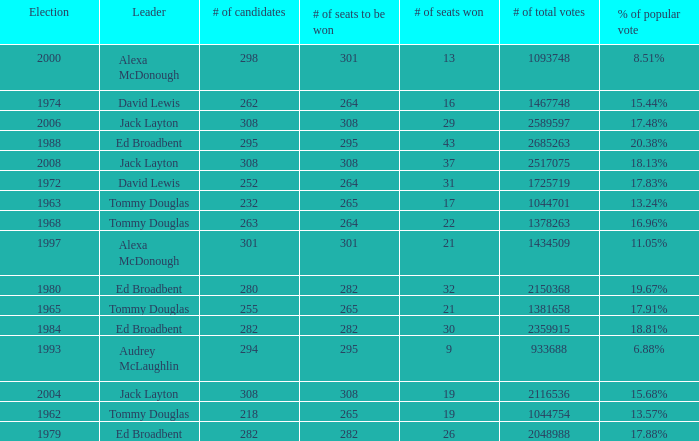Parse the full table. {'header': ['Election', 'Leader', '# of candidates', '# of seats to be won', '# of seats won', '# of total votes', '% of popular vote'], 'rows': [['2000', 'Alexa McDonough', '298', '301', '13', '1093748', '8.51%'], ['1974', 'David Lewis', '262', '264', '16', '1467748', '15.44%'], ['2006', 'Jack Layton', '308', '308', '29', '2589597', '17.48%'], ['1988', 'Ed Broadbent', '295', '295', '43', '2685263', '20.38%'], ['2008', 'Jack Layton', '308', '308', '37', '2517075', '18.13%'], ['1972', 'David Lewis', '252', '264', '31', '1725719', '17.83%'], ['1963', 'Tommy Douglas', '232', '265', '17', '1044701', '13.24%'], ['1968', 'Tommy Douglas', '263', '264', '22', '1378263', '16.96%'], ['1997', 'Alexa McDonough', '301', '301', '21', '1434509', '11.05%'], ['1980', 'Ed Broadbent', '280', '282', '32', '2150368', '19.67%'], ['1965', 'Tommy Douglas', '255', '265', '21', '1381658', '17.91%'], ['1984', 'Ed Broadbent', '282', '282', '30', '2359915', '18.81%'], ['1993', 'Audrey McLaughlin', '294', '295', '9', '933688', '6.88%'], ['2004', 'Jack Layton', '308', '308', '19', '2116536', '15.68%'], ['1962', 'Tommy Douglas', '218', '265', '19', '1044754', '13.57%'], ['1979', 'Ed Broadbent', '282', '282', '26', '2048988', '17.88%']]} Name the number of total votes for # of seats won being 30 2359915.0. 